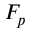<formula> <loc_0><loc_0><loc_500><loc_500>F _ { p }</formula> 